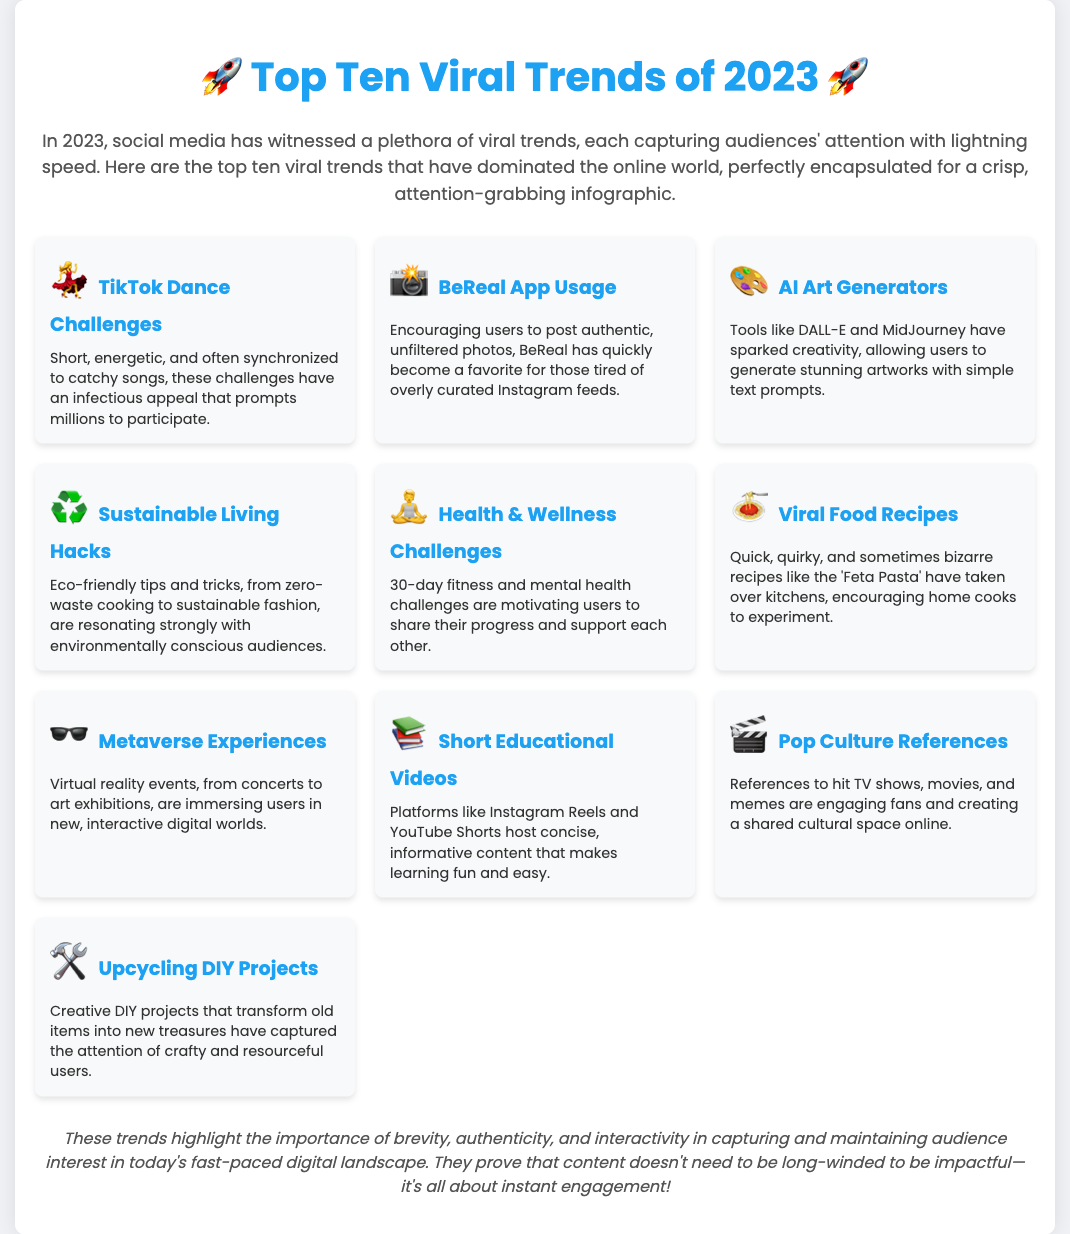What is the title of the infographic? The title of the infographic is prominently displayed at the top of the document.
Answer: Top Ten Viral Trends of 2023 How many viral trends are listed in the infographic? The document states that there are ten viral trends featured in the infographic.
Answer: Ten Which trend involves posting unfiltered photos? This trend encourages users to share authentic moments rather than curated content.
Answer: BeReal App Usage What type of content do TikTok Dance Challenges typically include? The description mentions that this trend is built around short, energetic performances set to music.
Answer: Dance Challenges What is the primary focus of Sustainable Living Hacks? The description highlights eco-friendly tips related to daily life and lifestyle choices.
Answer: Eco-friendly tips Which trend utilizes tools like DALL-E? This trend leverages AI technologies to create visual artworks from text.
Answer: AI Art Generators What do Short Educational Videos aim to achieve? The content focuses on delivering concise, informative lessons in an engaging format.
Answer: Informative content Which emoji represents Metaverse Experiences? The emoji used to symbolize this trend in the infographic is specified.
Answer: 🕶️ What key factor is highlighted in the conclusion regarding engaging content? The conclusion emphasizes a specific quality necessary for maintaining audience interest in digital content.
Answer: Brevity What is the general theme of the document? The document presents a series of viral trends and their characteristics in social media in a concise and engaging manner.
Answer: Viral trends 